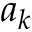Convert formula to latex. <formula><loc_0><loc_0><loc_500><loc_500>a _ { k }</formula> 